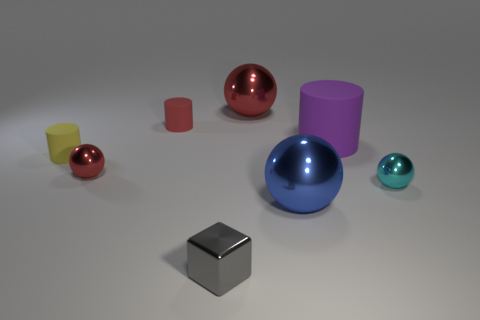Is the number of yellow rubber cylinders less than the number of rubber objects?
Your answer should be very brief. Yes. How many things are either small gray cubes or things left of the big matte thing?
Offer a terse response. 6. Are there any large purple cylinders made of the same material as the gray thing?
Your answer should be compact. No. There is a cyan object that is the same size as the yellow thing; what material is it?
Your answer should be compact. Metal. There is a sphere behind the matte object that is on the right side of the small gray thing; what is it made of?
Keep it short and to the point. Metal. Do the small metallic object right of the small block and the red rubber thing have the same shape?
Your answer should be very brief. No. There is another tiny cylinder that is made of the same material as the red cylinder; what color is it?
Offer a very short reply. Yellow. What material is the purple thing to the right of the big blue shiny sphere?
Make the answer very short. Rubber. There is a small cyan shiny object; does it have the same shape as the tiny matte thing on the left side of the small red cylinder?
Offer a very short reply. No. There is a tiny object that is on the right side of the red matte object and behind the tiny gray shiny thing; what material is it?
Provide a short and direct response. Metal. 